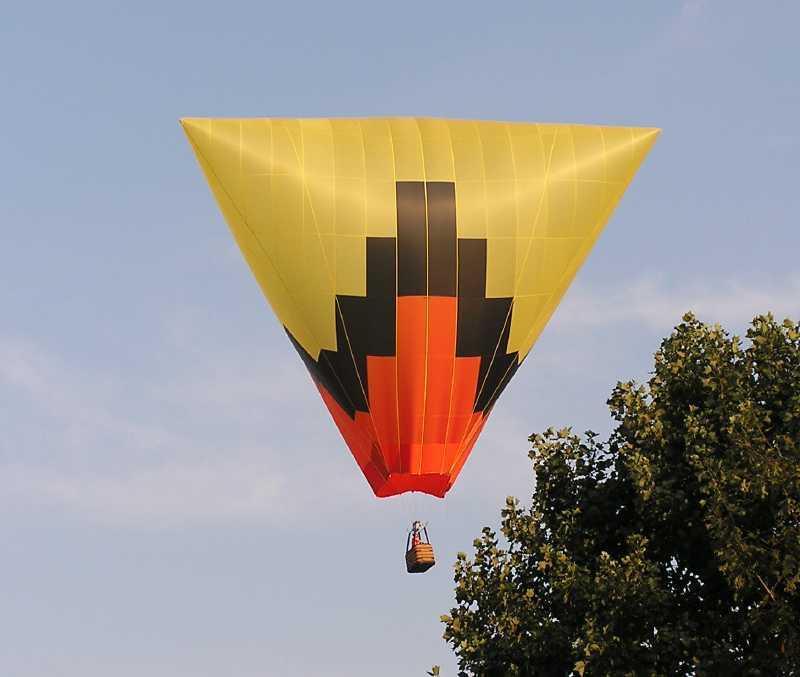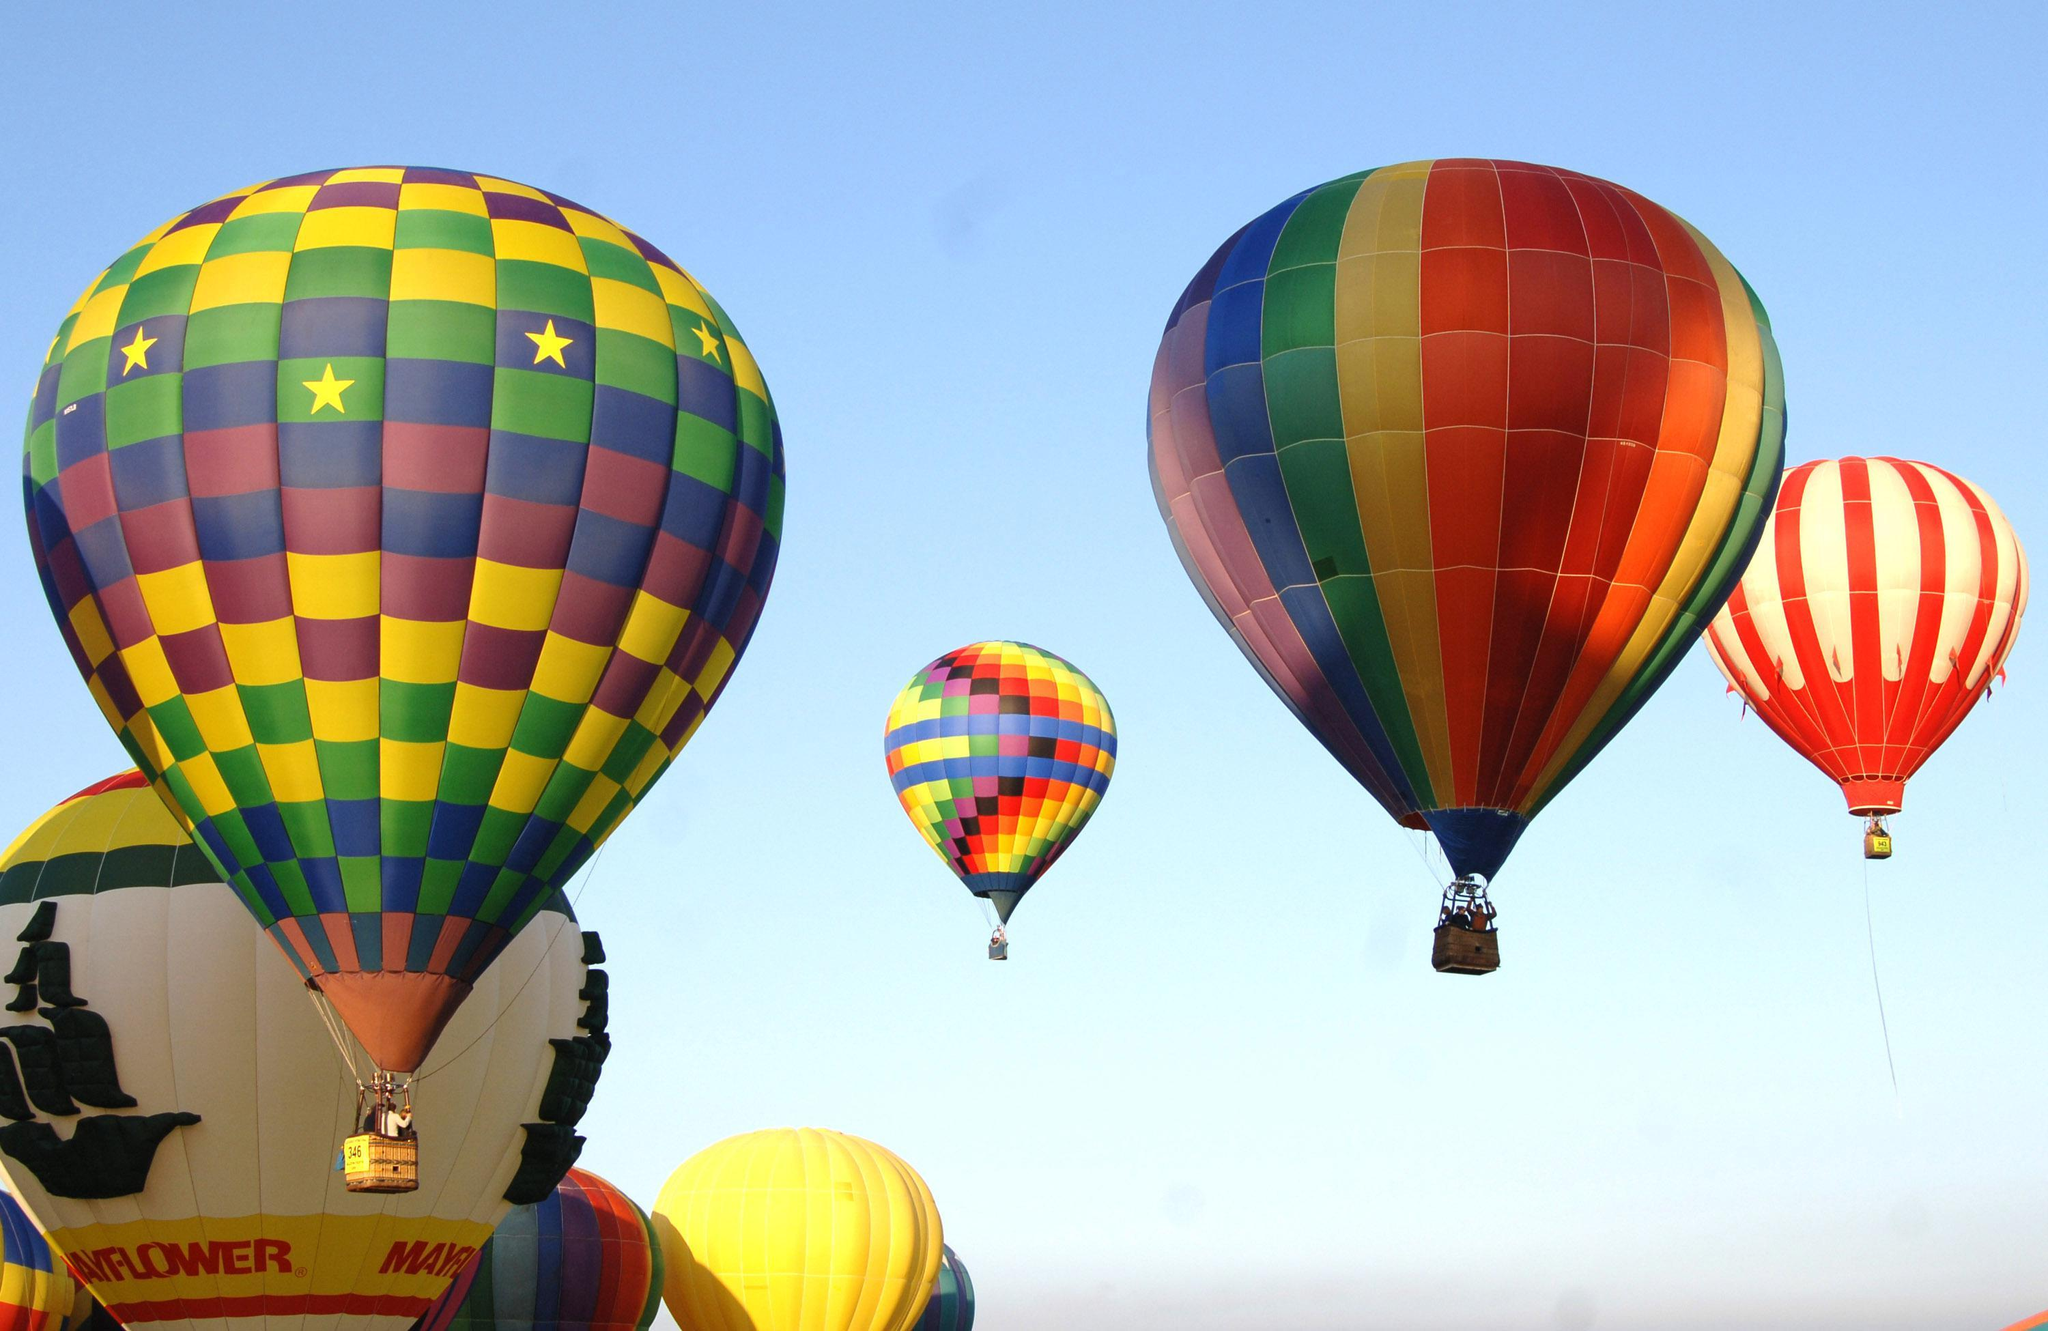The first image is the image on the left, the second image is the image on the right. For the images displayed, is the sentence "Only one image in the pair contains a single balloon." factually correct? Answer yes or no. Yes. 